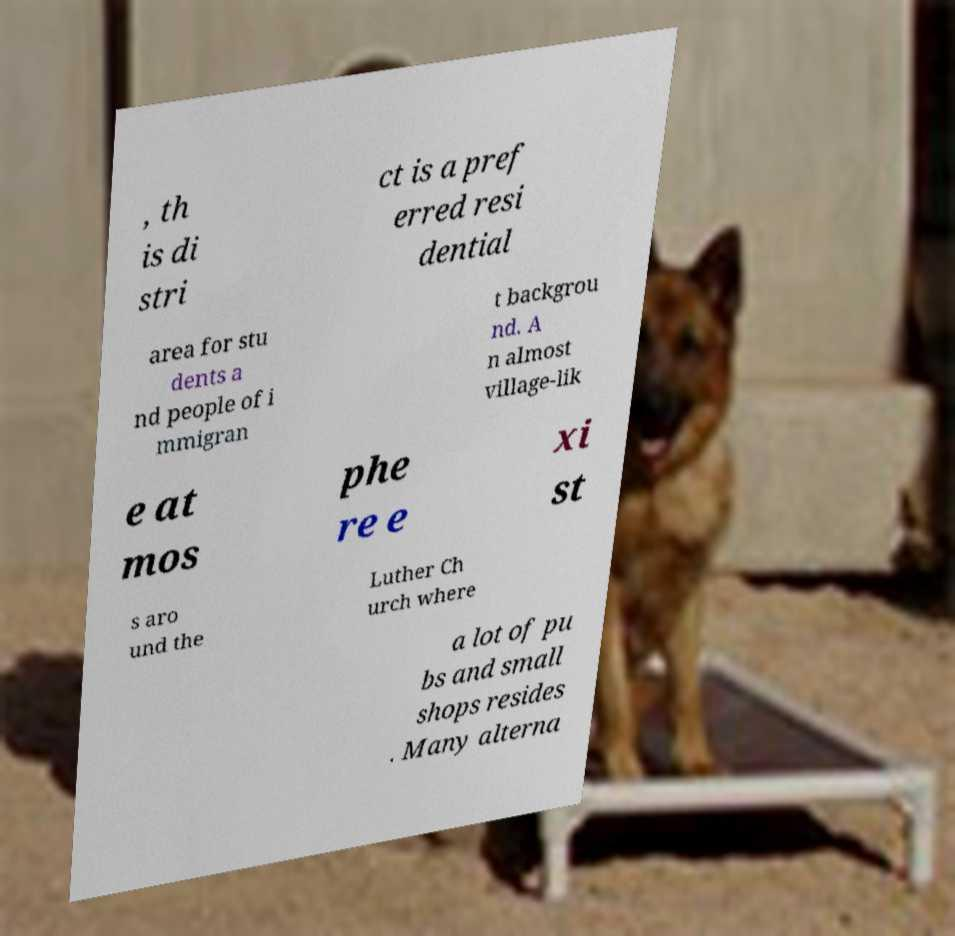Can you accurately transcribe the text from the provided image for me? , th is di stri ct is a pref erred resi dential area for stu dents a nd people of i mmigran t backgrou nd. A n almost village-lik e at mos phe re e xi st s aro und the Luther Ch urch where a lot of pu bs and small shops resides . Many alterna 